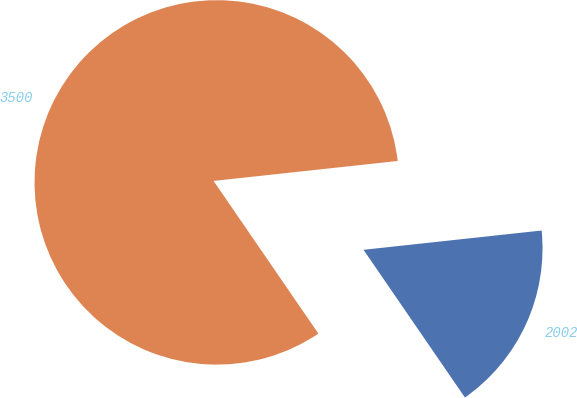<chart> <loc_0><loc_0><loc_500><loc_500><pie_chart><fcel>2002<fcel>3500<nl><fcel>17.14%<fcel>82.86%<nl></chart> 